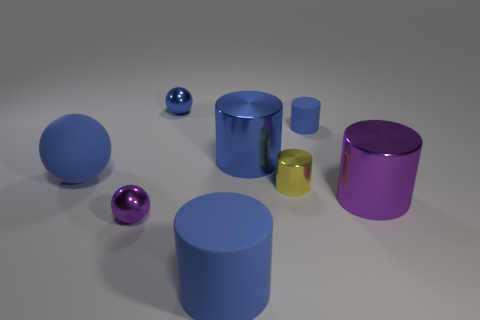How many other objects are the same material as the tiny yellow cylinder?
Offer a terse response. 4. Does the large purple cylinder have the same material as the tiny cylinder on the left side of the small blue rubber cylinder?
Give a very brief answer. Yes. Are there fewer spheres left of the large blue shiny thing than spheres in front of the tiny purple shiny object?
Ensure brevity in your answer.  No. There is a big metallic cylinder that is in front of the blue matte sphere; what color is it?
Provide a succinct answer. Purple. How many other objects are the same color as the small metallic cylinder?
Your answer should be very brief. 0. Do the blue object in front of the purple shiny sphere and the tiny blue matte object have the same size?
Offer a very short reply. No. Are there the same number of tiny cylinders and tiny purple things?
Make the answer very short. No. What number of shiny things are behind the yellow thing?
Provide a succinct answer. 2. Are there any blue shiny spheres that have the same size as the yellow metallic cylinder?
Give a very brief answer. Yes. Does the tiny metallic cylinder have the same color as the large rubber cylinder?
Offer a terse response. No. 